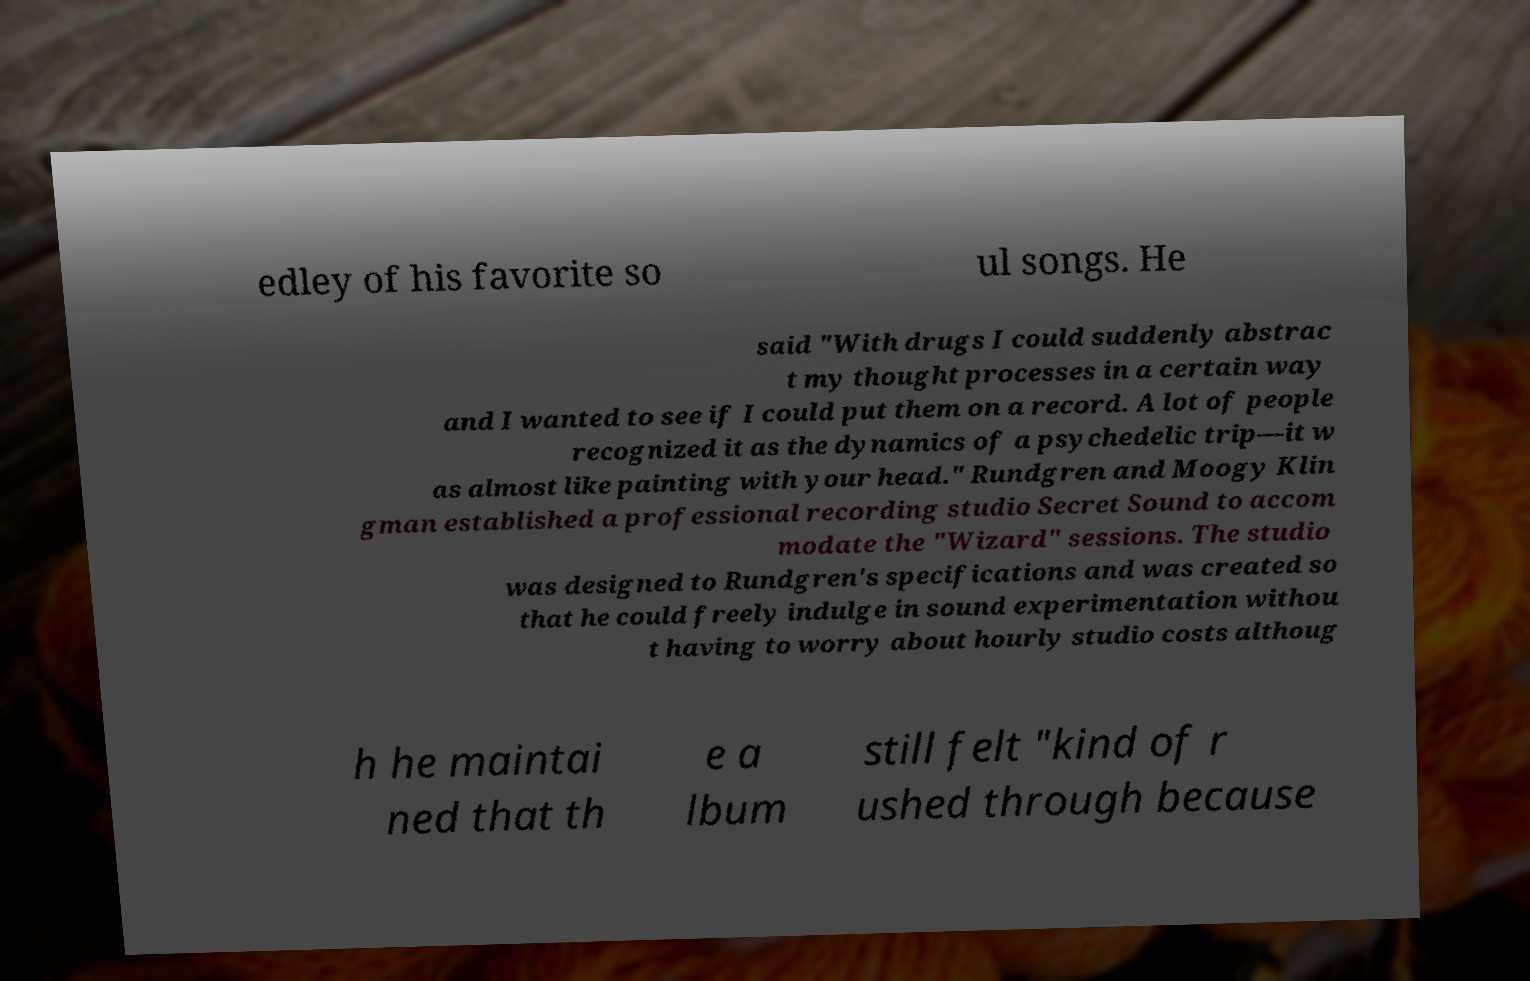Please read and relay the text visible in this image. What does it say? edley of his favorite so ul songs. He said "With drugs I could suddenly abstrac t my thought processes in a certain way and I wanted to see if I could put them on a record. A lot of people recognized it as the dynamics of a psychedelic trip—it w as almost like painting with your head." Rundgren and Moogy Klin gman established a professional recording studio Secret Sound to accom modate the "Wizard" sessions. The studio was designed to Rundgren's specifications and was created so that he could freely indulge in sound experimentation withou t having to worry about hourly studio costs althoug h he maintai ned that th e a lbum still felt "kind of r ushed through because 